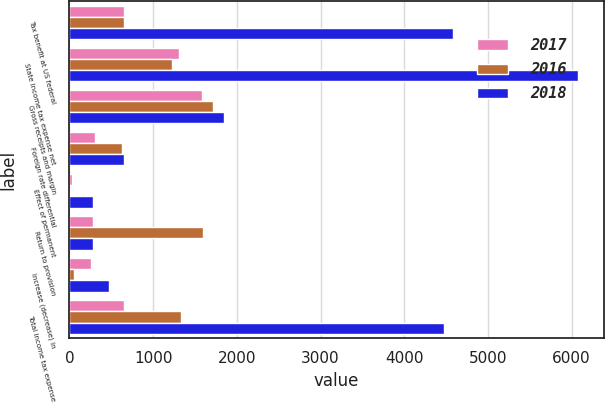<chart> <loc_0><loc_0><loc_500><loc_500><stacked_bar_chart><ecel><fcel>Tax benefit at US federal<fcel>State income tax expense net<fcel>Gross receipts and margin<fcel>Foreign rate differential<fcel>Effect of permanent<fcel>Return to provision<fcel>Increase (decrease) in<fcel>Total income tax expense<nl><fcel>2017<fcel>647<fcel>1313<fcel>1580<fcel>301<fcel>34<fcel>278<fcel>253<fcel>647<nl><fcel>2016<fcel>647<fcel>1222<fcel>1716<fcel>632<fcel>6<fcel>1597<fcel>57<fcel>1333<nl><fcel>2018<fcel>4581<fcel>6081<fcel>1847<fcel>647<fcel>280<fcel>287<fcel>472<fcel>4473<nl></chart> 